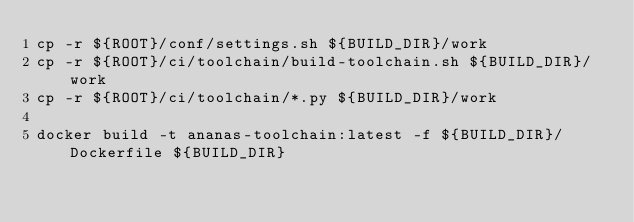Convert code to text. <code><loc_0><loc_0><loc_500><loc_500><_Bash_>cp -r ${ROOT}/conf/settings.sh ${BUILD_DIR}/work
cp -r ${ROOT}/ci/toolchain/build-toolchain.sh ${BUILD_DIR}/work
cp -r ${ROOT}/ci/toolchain/*.py ${BUILD_DIR}/work

docker build -t ananas-toolchain:latest -f ${BUILD_DIR}/Dockerfile ${BUILD_DIR}
</code> 